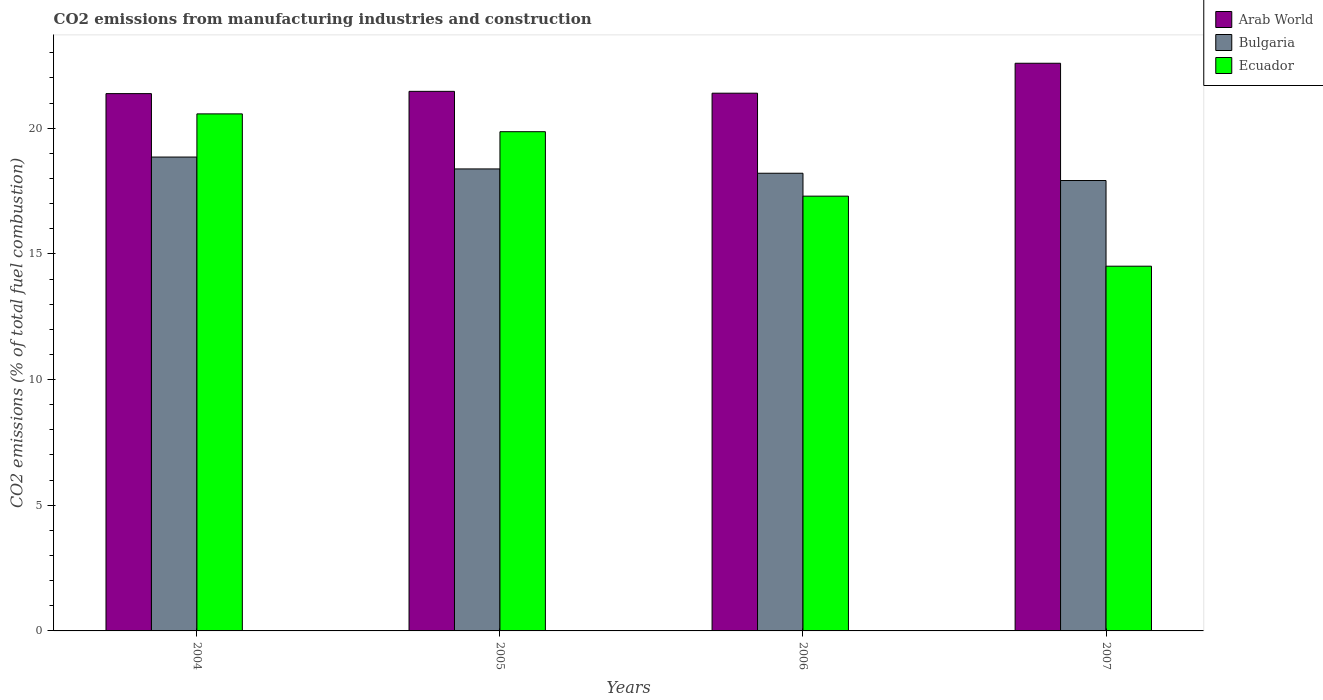How many groups of bars are there?
Provide a short and direct response. 4. Are the number of bars on each tick of the X-axis equal?
Provide a succinct answer. Yes. How many bars are there on the 4th tick from the left?
Your answer should be very brief. 3. In how many cases, is the number of bars for a given year not equal to the number of legend labels?
Provide a short and direct response. 0. What is the amount of CO2 emitted in Arab World in 2007?
Ensure brevity in your answer.  22.58. Across all years, what is the maximum amount of CO2 emitted in Bulgaria?
Give a very brief answer. 18.85. Across all years, what is the minimum amount of CO2 emitted in Bulgaria?
Provide a short and direct response. 17.92. In which year was the amount of CO2 emitted in Ecuador maximum?
Keep it short and to the point. 2004. In which year was the amount of CO2 emitted in Ecuador minimum?
Offer a terse response. 2007. What is the total amount of CO2 emitted in Bulgaria in the graph?
Offer a very short reply. 73.36. What is the difference between the amount of CO2 emitted in Ecuador in 2004 and that in 2006?
Offer a very short reply. 3.27. What is the difference between the amount of CO2 emitted in Arab World in 2007 and the amount of CO2 emitted in Bulgaria in 2005?
Your response must be concise. 4.2. What is the average amount of CO2 emitted in Bulgaria per year?
Your answer should be very brief. 18.34. In the year 2005, what is the difference between the amount of CO2 emitted in Arab World and amount of CO2 emitted in Bulgaria?
Keep it short and to the point. 3.09. In how many years, is the amount of CO2 emitted in Ecuador greater than 14 %?
Ensure brevity in your answer.  4. What is the ratio of the amount of CO2 emitted in Ecuador in 2005 to that in 2007?
Your answer should be very brief. 1.37. Is the amount of CO2 emitted in Ecuador in 2005 less than that in 2006?
Offer a terse response. No. What is the difference between the highest and the second highest amount of CO2 emitted in Bulgaria?
Your response must be concise. 0.47. What is the difference between the highest and the lowest amount of CO2 emitted in Arab World?
Your response must be concise. 1.21. What does the 2nd bar from the right in 2005 represents?
Provide a short and direct response. Bulgaria. How many bars are there?
Make the answer very short. 12. How many years are there in the graph?
Your answer should be very brief. 4. Are the values on the major ticks of Y-axis written in scientific E-notation?
Ensure brevity in your answer.  No. Does the graph contain any zero values?
Your answer should be compact. No. Does the graph contain grids?
Offer a terse response. No. How many legend labels are there?
Provide a succinct answer. 3. How are the legend labels stacked?
Give a very brief answer. Vertical. What is the title of the graph?
Offer a terse response. CO2 emissions from manufacturing industries and construction. What is the label or title of the Y-axis?
Keep it short and to the point. CO2 emissions (% of total fuel combustion). What is the CO2 emissions (% of total fuel combustion) of Arab World in 2004?
Offer a terse response. 21.38. What is the CO2 emissions (% of total fuel combustion) in Bulgaria in 2004?
Offer a very short reply. 18.85. What is the CO2 emissions (% of total fuel combustion) in Ecuador in 2004?
Your response must be concise. 20.57. What is the CO2 emissions (% of total fuel combustion) in Arab World in 2005?
Your response must be concise. 21.47. What is the CO2 emissions (% of total fuel combustion) of Bulgaria in 2005?
Keep it short and to the point. 18.38. What is the CO2 emissions (% of total fuel combustion) in Ecuador in 2005?
Make the answer very short. 19.86. What is the CO2 emissions (% of total fuel combustion) of Arab World in 2006?
Ensure brevity in your answer.  21.39. What is the CO2 emissions (% of total fuel combustion) in Bulgaria in 2006?
Your response must be concise. 18.21. What is the CO2 emissions (% of total fuel combustion) of Ecuador in 2006?
Offer a very short reply. 17.3. What is the CO2 emissions (% of total fuel combustion) of Arab World in 2007?
Provide a succinct answer. 22.58. What is the CO2 emissions (% of total fuel combustion) of Bulgaria in 2007?
Your response must be concise. 17.92. What is the CO2 emissions (% of total fuel combustion) of Ecuador in 2007?
Your answer should be very brief. 14.51. Across all years, what is the maximum CO2 emissions (% of total fuel combustion) in Arab World?
Your answer should be very brief. 22.58. Across all years, what is the maximum CO2 emissions (% of total fuel combustion) of Bulgaria?
Offer a terse response. 18.85. Across all years, what is the maximum CO2 emissions (% of total fuel combustion) in Ecuador?
Provide a short and direct response. 20.57. Across all years, what is the minimum CO2 emissions (% of total fuel combustion) in Arab World?
Your response must be concise. 21.38. Across all years, what is the minimum CO2 emissions (% of total fuel combustion) in Bulgaria?
Offer a terse response. 17.92. Across all years, what is the minimum CO2 emissions (% of total fuel combustion) of Ecuador?
Make the answer very short. 14.51. What is the total CO2 emissions (% of total fuel combustion) of Arab World in the graph?
Provide a short and direct response. 86.82. What is the total CO2 emissions (% of total fuel combustion) of Bulgaria in the graph?
Provide a short and direct response. 73.36. What is the total CO2 emissions (% of total fuel combustion) in Ecuador in the graph?
Give a very brief answer. 72.24. What is the difference between the CO2 emissions (% of total fuel combustion) of Arab World in 2004 and that in 2005?
Make the answer very short. -0.09. What is the difference between the CO2 emissions (% of total fuel combustion) of Bulgaria in 2004 and that in 2005?
Offer a very short reply. 0.47. What is the difference between the CO2 emissions (% of total fuel combustion) in Ecuador in 2004 and that in 2005?
Make the answer very short. 0.71. What is the difference between the CO2 emissions (% of total fuel combustion) in Arab World in 2004 and that in 2006?
Provide a succinct answer. -0.02. What is the difference between the CO2 emissions (% of total fuel combustion) in Bulgaria in 2004 and that in 2006?
Offer a terse response. 0.64. What is the difference between the CO2 emissions (% of total fuel combustion) in Ecuador in 2004 and that in 2006?
Provide a succinct answer. 3.27. What is the difference between the CO2 emissions (% of total fuel combustion) of Arab World in 2004 and that in 2007?
Give a very brief answer. -1.21. What is the difference between the CO2 emissions (% of total fuel combustion) of Bulgaria in 2004 and that in 2007?
Provide a succinct answer. 0.93. What is the difference between the CO2 emissions (% of total fuel combustion) in Ecuador in 2004 and that in 2007?
Your response must be concise. 6.06. What is the difference between the CO2 emissions (% of total fuel combustion) of Arab World in 2005 and that in 2006?
Ensure brevity in your answer.  0.07. What is the difference between the CO2 emissions (% of total fuel combustion) in Bulgaria in 2005 and that in 2006?
Keep it short and to the point. 0.17. What is the difference between the CO2 emissions (% of total fuel combustion) of Ecuador in 2005 and that in 2006?
Your answer should be very brief. 2.56. What is the difference between the CO2 emissions (% of total fuel combustion) of Arab World in 2005 and that in 2007?
Make the answer very short. -1.12. What is the difference between the CO2 emissions (% of total fuel combustion) of Bulgaria in 2005 and that in 2007?
Provide a succinct answer. 0.46. What is the difference between the CO2 emissions (% of total fuel combustion) of Ecuador in 2005 and that in 2007?
Make the answer very short. 5.35. What is the difference between the CO2 emissions (% of total fuel combustion) of Arab World in 2006 and that in 2007?
Your answer should be compact. -1.19. What is the difference between the CO2 emissions (% of total fuel combustion) in Bulgaria in 2006 and that in 2007?
Your answer should be very brief. 0.29. What is the difference between the CO2 emissions (% of total fuel combustion) of Ecuador in 2006 and that in 2007?
Keep it short and to the point. 2.79. What is the difference between the CO2 emissions (% of total fuel combustion) of Arab World in 2004 and the CO2 emissions (% of total fuel combustion) of Bulgaria in 2005?
Make the answer very short. 3. What is the difference between the CO2 emissions (% of total fuel combustion) of Arab World in 2004 and the CO2 emissions (% of total fuel combustion) of Ecuador in 2005?
Keep it short and to the point. 1.52. What is the difference between the CO2 emissions (% of total fuel combustion) in Bulgaria in 2004 and the CO2 emissions (% of total fuel combustion) in Ecuador in 2005?
Your answer should be compact. -1.01. What is the difference between the CO2 emissions (% of total fuel combustion) in Arab World in 2004 and the CO2 emissions (% of total fuel combustion) in Bulgaria in 2006?
Provide a succinct answer. 3.17. What is the difference between the CO2 emissions (% of total fuel combustion) of Arab World in 2004 and the CO2 emissions (% of total fuel combustion) of Ecuador in 2006?
Give a very brief answer. 4.08. What is the difference between the CO2 emissions (% of total fuel combustion) of Bulgaria in 2004 and the CO2 emissions (% of total fuel combustion) of Ecuador in 2006?
Keep it short and to the point. 1.56. What is the difference between the CO2 emissions (% of total fuel combustion) of Arab World in 2004 and the CO2 emissions (% of total fuel combustion) of Bulgaria in 2007?
Provide a succinct answer. 3.46. What is the difference between the CO2 emissions (% of total fuel combustion) of Arab World in 2004 and the CO2 emissions (% of total fuel combustion) of Ecuador in 2007?
Give a very brief answer. 6.87. What is the difference between the CO2 emissions (% of total fuel combustion) of Bulgaria in 2004 and the CO2 emissions (% of total fuel combustion) of Ecuador in 2007?
Keep it short and to the point. 4.34. What is the difference between the CO2 emissions (% of total fuel combustion) in Arab World in 2005 and the CO2 emissions (% of total fuel combustion) in Bulgaria in 2006?
Give a very brief answer. 3.26. What is the difference between the CO2 emissions (% of total fuel combustion) of Arab World in 2005 and the CO2 emissions (% of total fuel combustion) of Ecuador in 2006?
Provide a succinct answer. 4.17. What is the difference between the CO2 emissions (% of total fuel combustion) of Bulgaria in 2005 and the CO2 emissions (% of total fuel combustion) of Ecuador in 2006?
Provide a succinct answer. 1.08. What is the difference between the CO2 emissions (% of total fuel combustion) in Arab World in 2005 and the CO2 emissions (% of total fuel combustion) in Bulgaria in 2007?
Offer a terse response. 3.55. What is the difference between the CO2 emissions (% of total fuel combustion) of Arab World in 2005 and the CO2 emissions (% of total fuel combustion) of Ecuador in 2007?
Ensure brevity in your answer.  6.96. What is the difference between the CO2 emissions (% of total fuel combustion) of Bulgaria in 2005 and the CO2 emissions (% of total fuel combustion) of Ecuador in 2007?
Offer a very short reply. 3.87. What is the difference between the CO2 emissions (% of total fuel combustion) of Arab World in 2006 and the CO2 emissions (% of total fuel combustion) of Bulgaria in 2007?
Offer a terse response. 3.47. What is the difference between the CO2 emissions (% of total fuel combustion) in Arab World in 2006 and the CO2 emissions (% of total fuel combustion) in Ecuador in 2007?
Your answer should be compact. 6.88. What is the difference between the CO2 emissions (% of total fuel combustion) in Bulgaria in 2006 and the CO2 emissions (% of total fuel combustion) in Ecuador in 2007?
Your answer should be compact. 3.7. What is the average CO2 emissions (% of total fuel combustion) of Arab World per year?
Provide a succinct answer. 21.7. What is the average CO2 emissions (% of total fuel combustion) in Bulgaria per year?
Ensure brevity in your answer.  18.34. What is the average CO2 emissions (% of total fuel combustion) in Ecuador per year?
Make the answer very short. 18.06. In the year 2004, what is the difference between the CO2 emissions (% of total fuel combustion) in Arab World and CO2 emissions (% of total fuel combustion) in Bulgaria?
Offer a very short reply. 2.52. In the year 2004, what is the difference between the CO2 emissions (% of total fuel combustion) in Arab World and CO2 emissions (% of total fuel combustion) in Ecuador?
Your answer should be compact. 0.81. In the year 2004, what is the difference between the CO2 emissions (% of total fuel combustion) of Bulgaria and CO2 emissions (% of total fuel combustion) of Ecuador?
Provide a short and direct response. -1.72. In the year 2005, what is the difference between the CO2 emissions (% of total fuel combustion) of Arab World and CO2 emissions (% of total fuel combustion) of Bulgaria?
Ensure brevity in your answer.  3.09. In the year 2005, what is the difference between the CO2 emissions (% of total fuel combustion) of Arab World and CO2 emissions (% of total fuel combustion) of Ecuador?
Offer a terse response. 1.61. In the year 2005, what is the difference between the CO2 emissions (% of total fuel combustion) of Bulgaria and CO2 emissions (% of total fuel combustion) of Ecuador?
Offer a terse response. -1.48. In the year 2006, what is the difference between the CO2 emissions (% of total fuel combustion) of Arab World and CO2 emissions (% of total fuel combustion) of Bulgaria?
Your response must be concise. 3.18. In the year 2006, what is the difference between the CO2 emissions (% of total fuel combustion) of Arab World and CO2 emissions (% of total fuel combustion) of Ecuador?
Your answer should be compact. 4.1. In the year 2006, what is the difference between the CO2 emissions (% of total fuel combustion) of Bulgaria and CO2 emissions (% of total fuel combustion) of Ecuador?
Your response must be concise. 0.91. In the year 2007, what is the difference between the CO2 emissions (% of total fuel combustion) of Arab World and CO2 emissions (% of total fuel combustion) of Bulgaria?
Your answer should be compact. 4.67. In the year 2007, what is the difference between the CO2 emissions (% of total fuel combustion) in Arab World and CO2 emissions (% of total fuel combustion) in Ecuador?
Your response must be concise. 8.07. In the year 2007, what is the difference between the CO2 emissions (% of total fuel combustion) in Bulgaria and CO2 emissions (% of total fuel combustion) in Ecuador?
Give a very brief answer. 3.41. What is the ratio of the CO2 emissions (% of total fuel combustion) of Arab World in 2004 to that in 2005?
Your answer should be compact. 1. What is the ratio of the CO2 emissions (% of total fuel combustion) in Bulgaria in 2004 to that in 2005?
Make the answer very short. 1.03. What is the ratio of the CO2 emissions (% of total fuel combustion) in Ecuador in 2004 to that in 2005?
Provide a short and direct response. 1.04. What is the ratio of the CO2 emissions (% of total fuel combustion) in Bulgaria in 2004 to that in 2006?
Your answer should be compact. 1.04. What is the ratio of the CO2 emissions (% of total fuel combustion) of Ecuador in 2004 to that in 2006?
Offer a very short reply. 1.19. What is the ratio of the CO2 emissions (% of total fuel combustion) of Arab World in 2004 to that in 2007?
Your answer should be very brief. 0.95. What is the ratio of the CO2 emissions (% of total fuel combustion) in Bulgaria in 2004 to that in 2007?
Make the answer very short. 1.05. What is the ratio of the CO2 emissions (% of total fuel combustion) of Ecuador in 2004 to that in 2007?
Your response must be concise. 1.42. What is the ratio of the CO2 emissions (% of total fuel combustion) in Arab World in 2005 to that in 2006?
Ensure brevity in your answer.  1. What is the ratio of the CO2 emissions (% of total fuel combustion) in Bulgaria in 2005 to that in 2006?
Give a very brief answer. 1.01. What is the ratio of the CO2 emissions (% of total fuel combustion) of Ecuador in 2005 to that in 2006?
Provide a short and direct response. 1.15. What is the ratio of the CO2 emissions (% of total fuel combustion) in Arab World in 2005 to that in 2007?
Offer a terse response. 0.95. What is the ratio of the CO2 emissions (% of total fuel combustion) in Bulgaria in 2005 to that in 2007?
Give a very brief answer. 1.03. What is the ratio of the CO2 emissions (% of total fuel combustion) of Ecuador in 2005 to that in 2007?
Offer a very short reply. 1.37. What is the ratio of the CO2 emissions (% of total fuel combustion) of Arab World in 2006 to that in 2007?
Give a very brief answer. 0.95. What is the ratio of the CO2 emissions (% of total fuel combustion) of Bulgaria in 2006 to that in 2007?
Your response must be concise. 1.02. What is the ratio of the CO2 emissions (% of total fuel combustion) in Ecuador in 2006 to that in 2007?
Offer a terse response. 1.19. What is the difference between the highest and the second highest CO2 emissions (% of total fuel combustion) of Arab World?
Make the answer very short. 1.12. What is the difference between the highest and the second highest CO2 emissions (% of total fuel combustion) of Bulgaria?
Your response must be concise. 0.47. What is the difference between the highest and the second highest CO2 emissions (% of total fuel combustion) in Ecuador?
Give a very brief answer. 0.71. What is the difference between the highest and the lowest CO2 emissions (% of total fuel combustion) of Arab World?
Provide a succinct answer. 1.21. What is the difference between the highest and the lowest CO2 emissions (% of total fuel combustion) in Bulgaria?
Your response must be concise. 0.93. What is the difference between the highest and the lowest CO2 emissions (% of total fuel combustion) of Ecuador?
Provide a succinct answer. 6.06. 